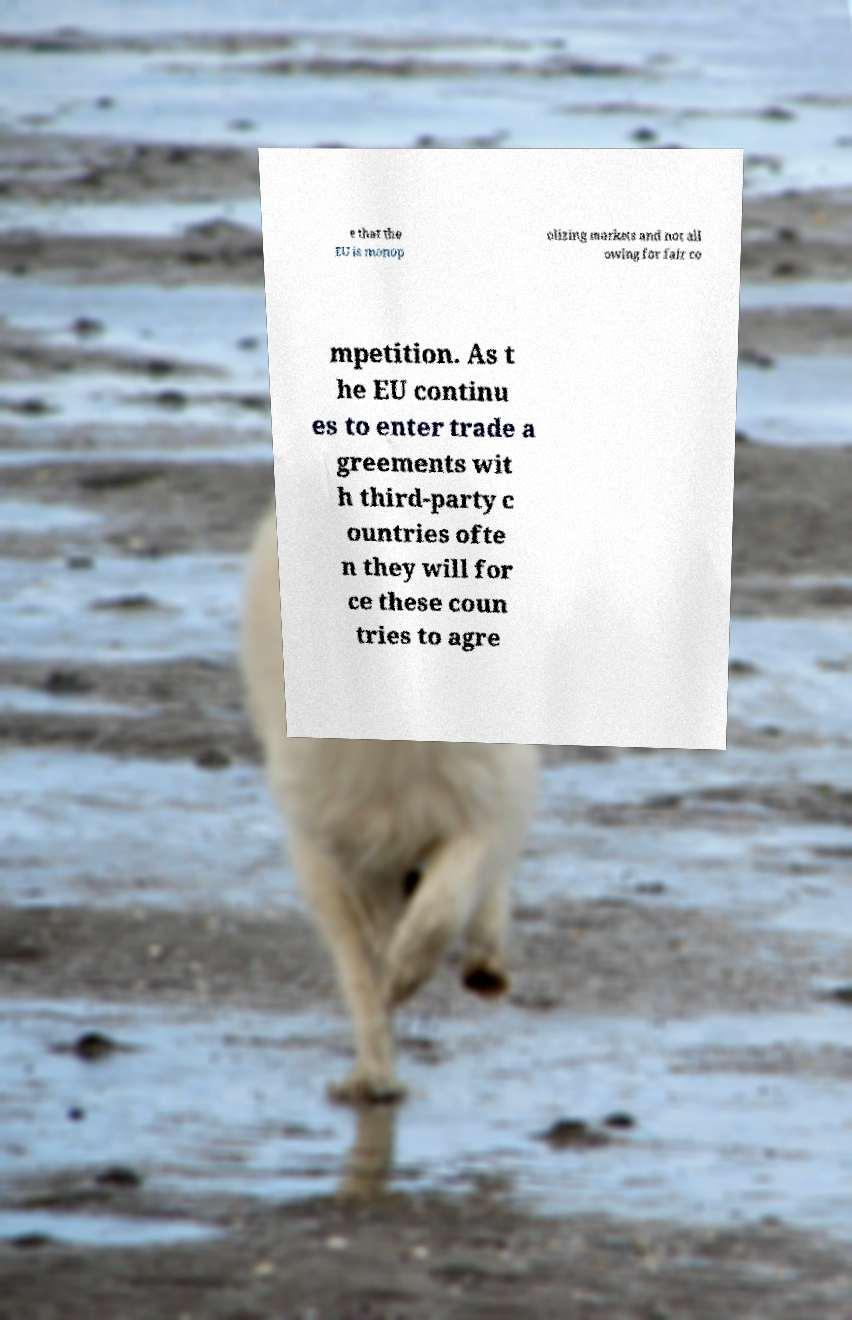Could you extract and type out the text from this image? e that the EU is monop olizing markets and not all owing for fair co mpetition. As t he EU continu es to enter trade a greements wit h third-party c ountries ofte n they will for ce these coun tries to agre 